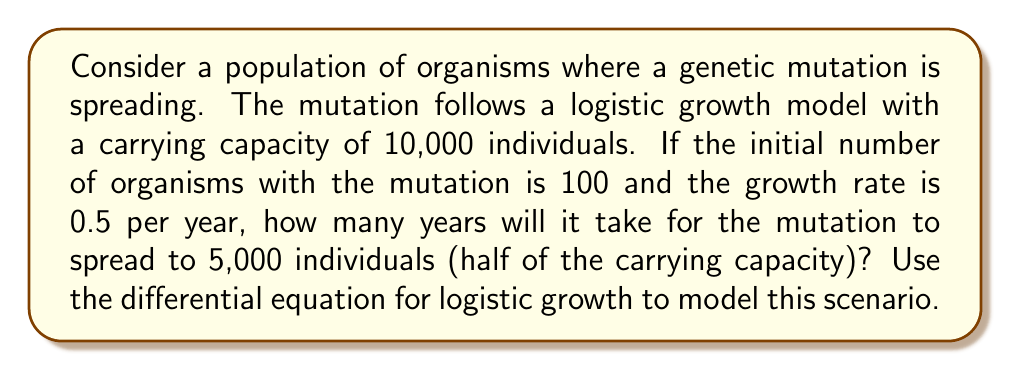Could you help me with this problem? Let's approach this step-by-step:

1) The logistic growth model is described by the differential equation:

   $$\frac{dP}{dt} = rP(1 - \frac{P}{K})$$

   Where:
   $P$ is the population size
   $t$ is time
   $r$ is the growth rate
   $K$ is the carrying capacity

2) Given:
   $K = 10,000$
   $r = 0.5$ per year
   $P_0 = 100$ (initial population)
   We need to find $t$ when $P = 5,000$

3) The solution to this differential equation is:

   $$P(t) = \frac{K}{1 + (\frac{K}{P_0} - 1)e^{-rt}}$$

4) Substituting our values:

   $$5000 = \frac{10000}{1 + (\frac{10000}{100} - 1)e^{-0.5t}}$$

5) Simplify:

   $$0.5 = \frac{1}{1 + 99e^{-0.5t}}$$

6) Solve for $t$:

   $$1 + 99e^{-0.5t} = 2$$
   $$99e^{-0.5t} = 1$$
   $$e^{-0.5t} = \frac{1}{99}$$
   $$-0.5t = \ln(\frac{1}{99})$$
   $$t = -2\ln(\frac{1}{99})$$
   $$t = 2\ln(99)$$

7) Calculate:

   $$t \approx 9.19$$ years
Answer: 9.19 years 